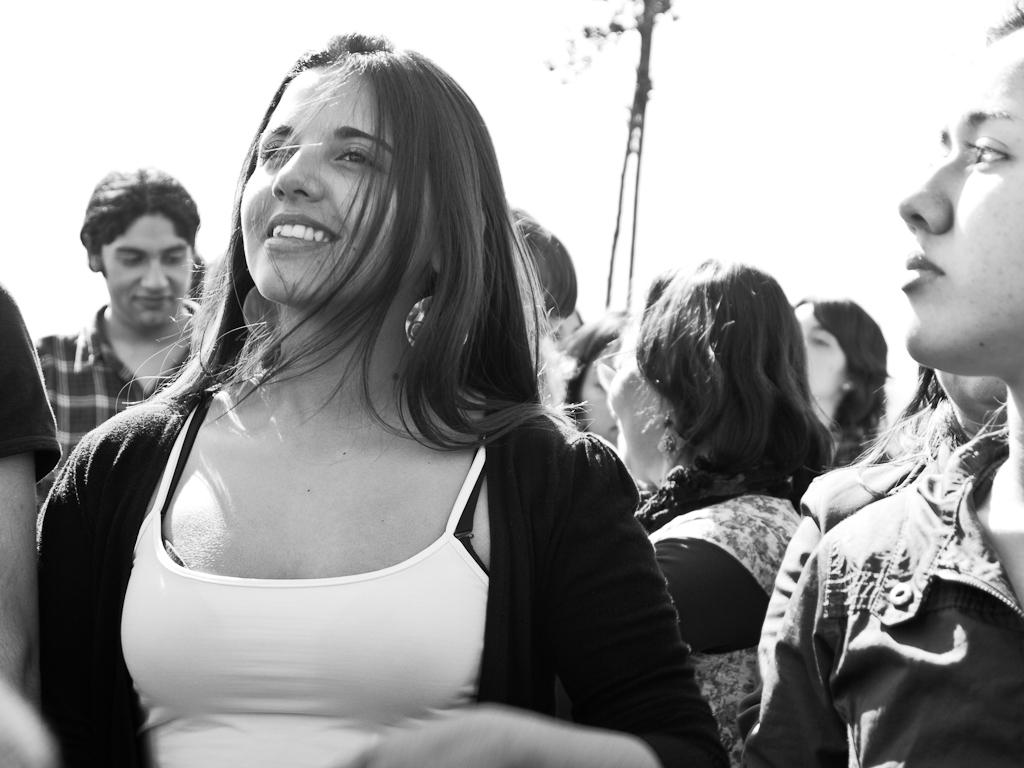Who or what can be seen in the image? There are people in the image. What object is present in the image besides the people? There is a pole in the image. What part of the natural environment is visible in the image? The sky is visible in the image. What is the color scheme of the image? The image is in black and white mode. Where is the library located in the image? There is no library present in the image. What type of growth can be observed on the pole in the image? There is no growth visible on the pole in the image. 